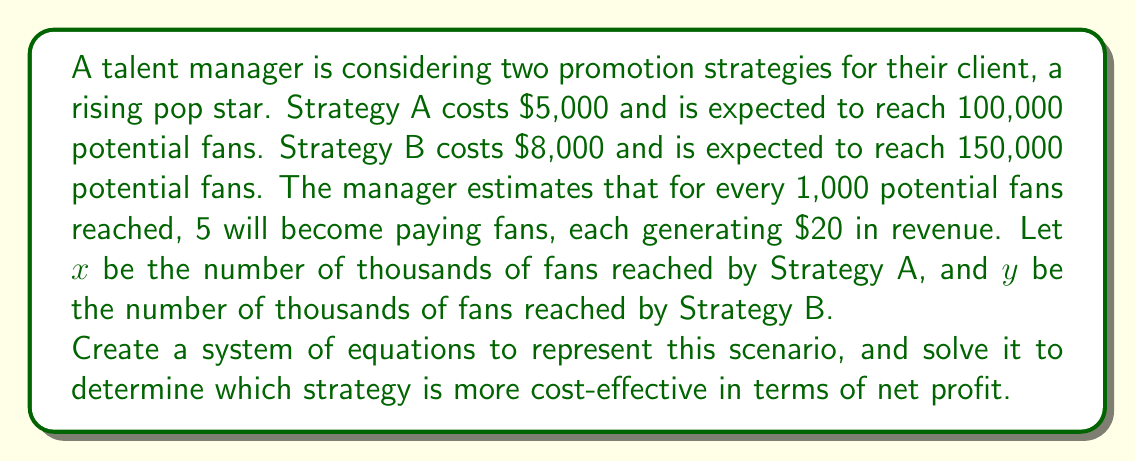Can you solve this math problem? Let's approach this step-by-step:

1) First, let's set up equations for the cost of each strategy:
   Strategy A: $5000 = 5x$
   Strategy B: $8000 = \frac{8y}{3}$

2) Now, let's create equations for the revenue generated by each strategy:
   Revenue A: $20 \cdot 5 \cdot x = 100x$
   Revenue B: $20 \cdot 5 \cdot y = 100y$

3) Net profit is revenue minus cost. Let's set up these equations:
   Net Profit A: $100x - 5x = 95x$
   Net Profit B: $100y - \frac{8y}{3} = 100y - \frac{8y}{3}$

4) To compare cost-effectiveness, we need to find $x$ and $y$. From the first equations:
   $x = 100$ (Strategy A reaches 100,000 fans)
   $y = 150$ (Strategy B reaches 150,000 fans)

5) Now let's calculate the net profit for each strategy:
   Net Profit A: $95 \cdot 100 = 9500$
   Net Profit B: $100 \cdot 150 - \frac{8}{3} \cdot 150 = 15000 - 400 = 14600$

6) To determine cost-effectiveness, we can calculate profit per dollar spent:
   Strategy A: $\frac{9500}{5000} = 1.9$
   Strategy B: $\frac{14600}{8000} = 1.825$

Therefore, while Strategy B generates more total profit, Strategy A is more cost-effective as it generates more profit per dollar spent.
Answer: Strategy A is more cost-effective, with a profit of $1.90 per dollar spent compared to $1.825 for Strategy B. 